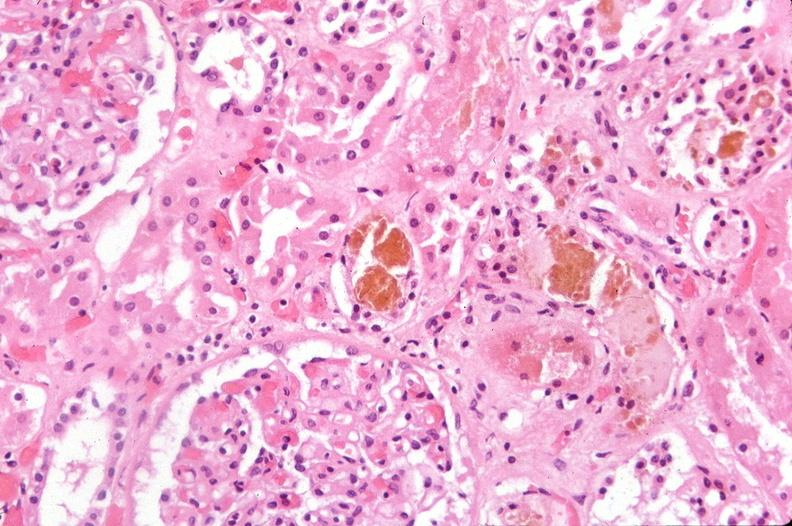does this image show kidney, bile in tubules and hypercellular glomeruli mesangial proliferation?
Answer the question using a single word or phrase. Yes 